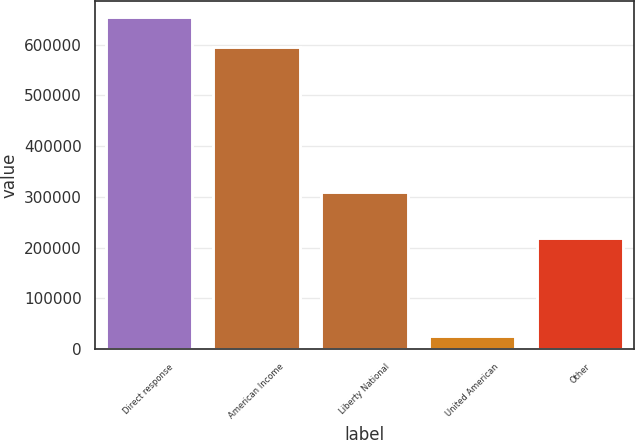Convert chart to OTSL. <chart><loc_0><loc_0><loc_500><loc_500><bar_chart><fcel>Direct response<fcel>American Income<fcel>Liberty National<fcel>United American<fcel>Other<nl><fcel>654370<fcel>596583<fcel>310475<fcel>24726<fcel>218669<nl></chart> 